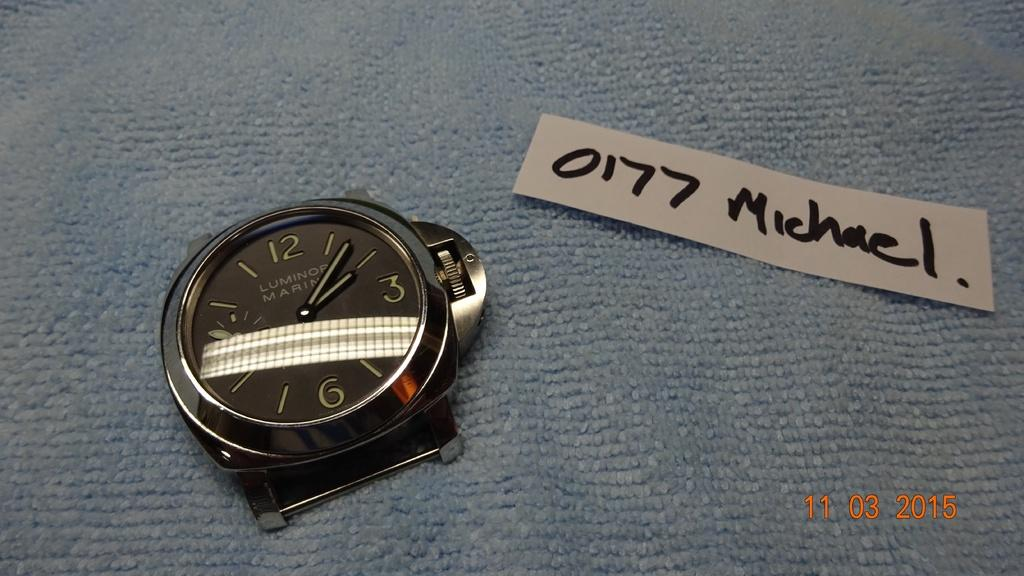<image>
Summarize the visual content of the image. The main component of a wrist watch is next to a piece of paper with 0177 Michael written on it, in a photo taken on 11/03/2015. 